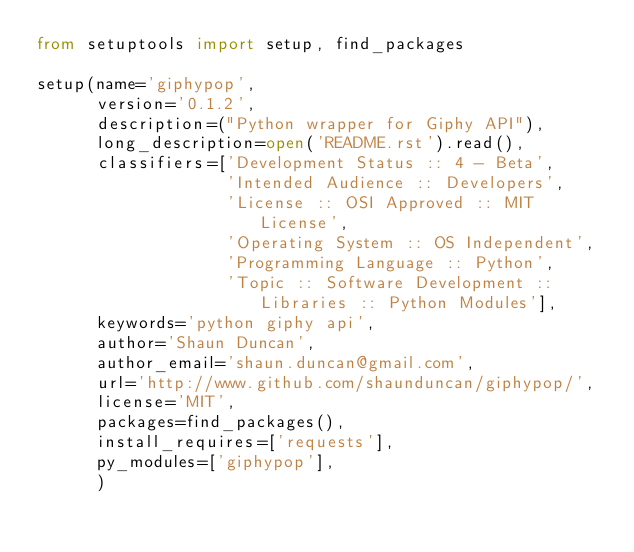<code> <loc_0><loc_0><loc_500><loc_500><_Python_>from setuptools import setup, find_packages

setup(name='giphypop',
      version='0.1.2',
      description=("Python wrapper for Giphy API"),
      long_description=open('README.rst').read(),
      classifiers=['Development Status :: 4 - Beta',
                   'Intended Audience :: Developers',
                   'License :: OSI Approved :: MIT License',
                   'Operating System :: OS Independent',
                   'Programming Language :: Python',
                   'Topic :: Software Development :: Libraries :: Python Modules'],
      keywords='python giphy api',
      author='Shaun Duncan',
      author_email='shaun.duncan@gmail.com',
      url='http://www.github.com/shaunduncan/giphypop/',
      license='MIT',
      packages=find_packages(),
      install_requires=['requests'],
      py_modules=['giphypop'],
      )
</code> 